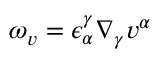Convert formula to latex. <formula><loc_0><loc_0><loc_500><loc_500>\omega _ { v } = \epsilon _ { \alpha } ^ { \gamma } \nabla _ { \gamma } v ^ { \alpha }</formula> 